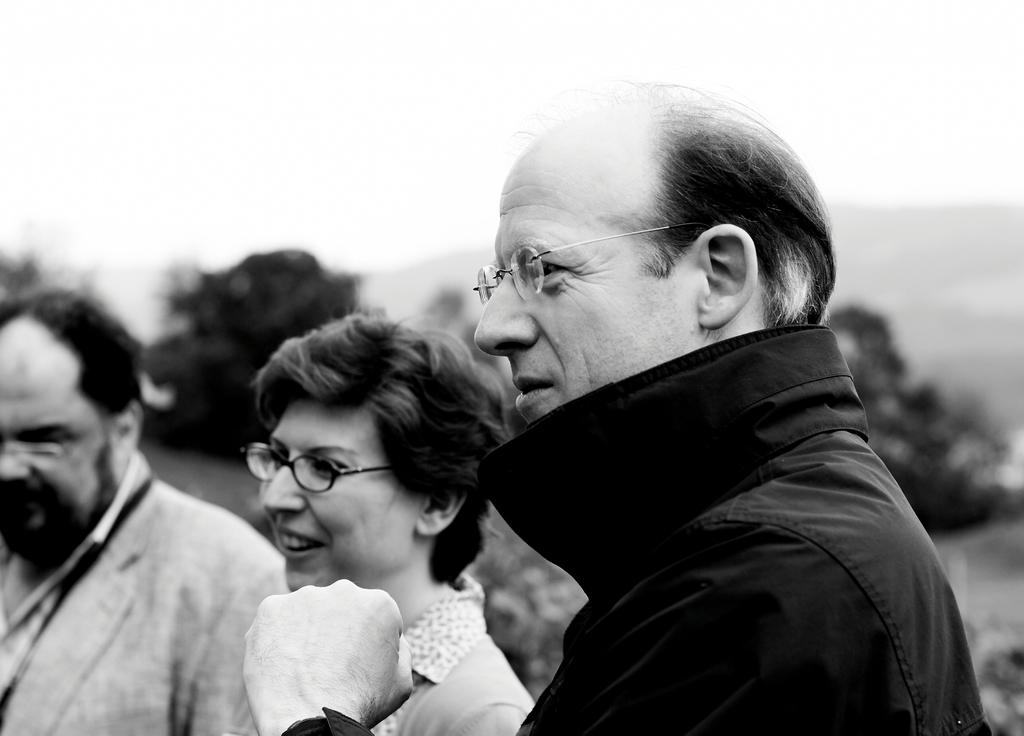How many people are in the image? There are three people in the image. What expressions do the people have? The people are smiling in the image. In which direction are the people looking? The people are looking to the left side of the image. What is the color scheme of the image? The image is black and white. What can be seen in the background of the image? There are trees and the sky visible in the background of the image. What type of comb is being used by the person on the right side of the image? There is no comb present in the image; it is a black and white image of three people smiling and looking to the left side. --- Facts: 1. There is a car in the image. 2. The car is red. 3. The car has four wheels. 4. There are people in the car. 5. The car is parked on the street. 6. There are trees on the side of the street. Absurd Topics: parrot, volcano, dance Conversation: What is the main subject of the image? The main subject of the image is a car. What color is the car? The car is red. How many wheels does the car have? The car has four wheels. Are there any passengers in the car? Yes, there are people in the car. Where is the car located in the image? The car is parked on the street. What can be seen on the side of the street? There are trees on the side of the street. Reasoning: Let's think step by step in order to produce the conversation. We start by identifying the identifying the main subject of the image, which is the car. Then, we describe the color and number of wheels of the car. Next, we mention the presence of passengers in the car and its location on the street. Finally, we describe the background elements, which are the trees on the side of the street. Each question is designed to elicit a specific detail about the image that is known from the provided facts. Absurd Question/Answer: Can you see a parrot sitting on the car's roof in the image? No, there is no parrot present in the image; it is a red car with four wheels parked on the street with people inside and trees on the side of the street. 